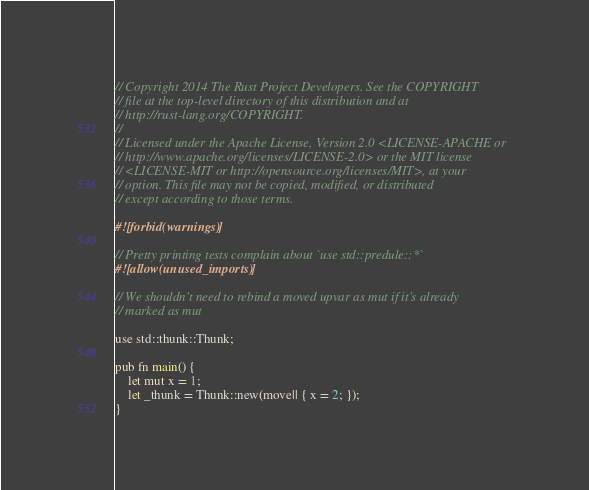<code> <loc_0><loc_0><loc_500><loc_500><_Rust_>// Copyright 2014 The Rust Project Developers. See the COPYRIGHT
// file at the top-level directory of this distribution and at
// http://rust-lang.org/COPYRIGHT.
//
// Licensed under the Apache License, Version 2.0 <LICENSE-APACHE or
// http://www.apache.org/licenses/LICENSE-2.0> or the MIT license
// <LICENSE-MIT or http://opensource.org/licenses/MIT>, at your
// option. This file may not be copied, modified, or distributed
// except according to those terms.

#![forbid(warnings)]

// Pretty printing tests complain about `use std::predule::*`
#![allow(unused_imports)]

// We shouldn't need to rebind a moved upvar as mut if it's already
// marked as mut

use std::thunk::Thunk;

pub fn main() {
    let mut x = 1;
    let _thunk = Thunk::new(move|| { x = 2; });
}
</code> 